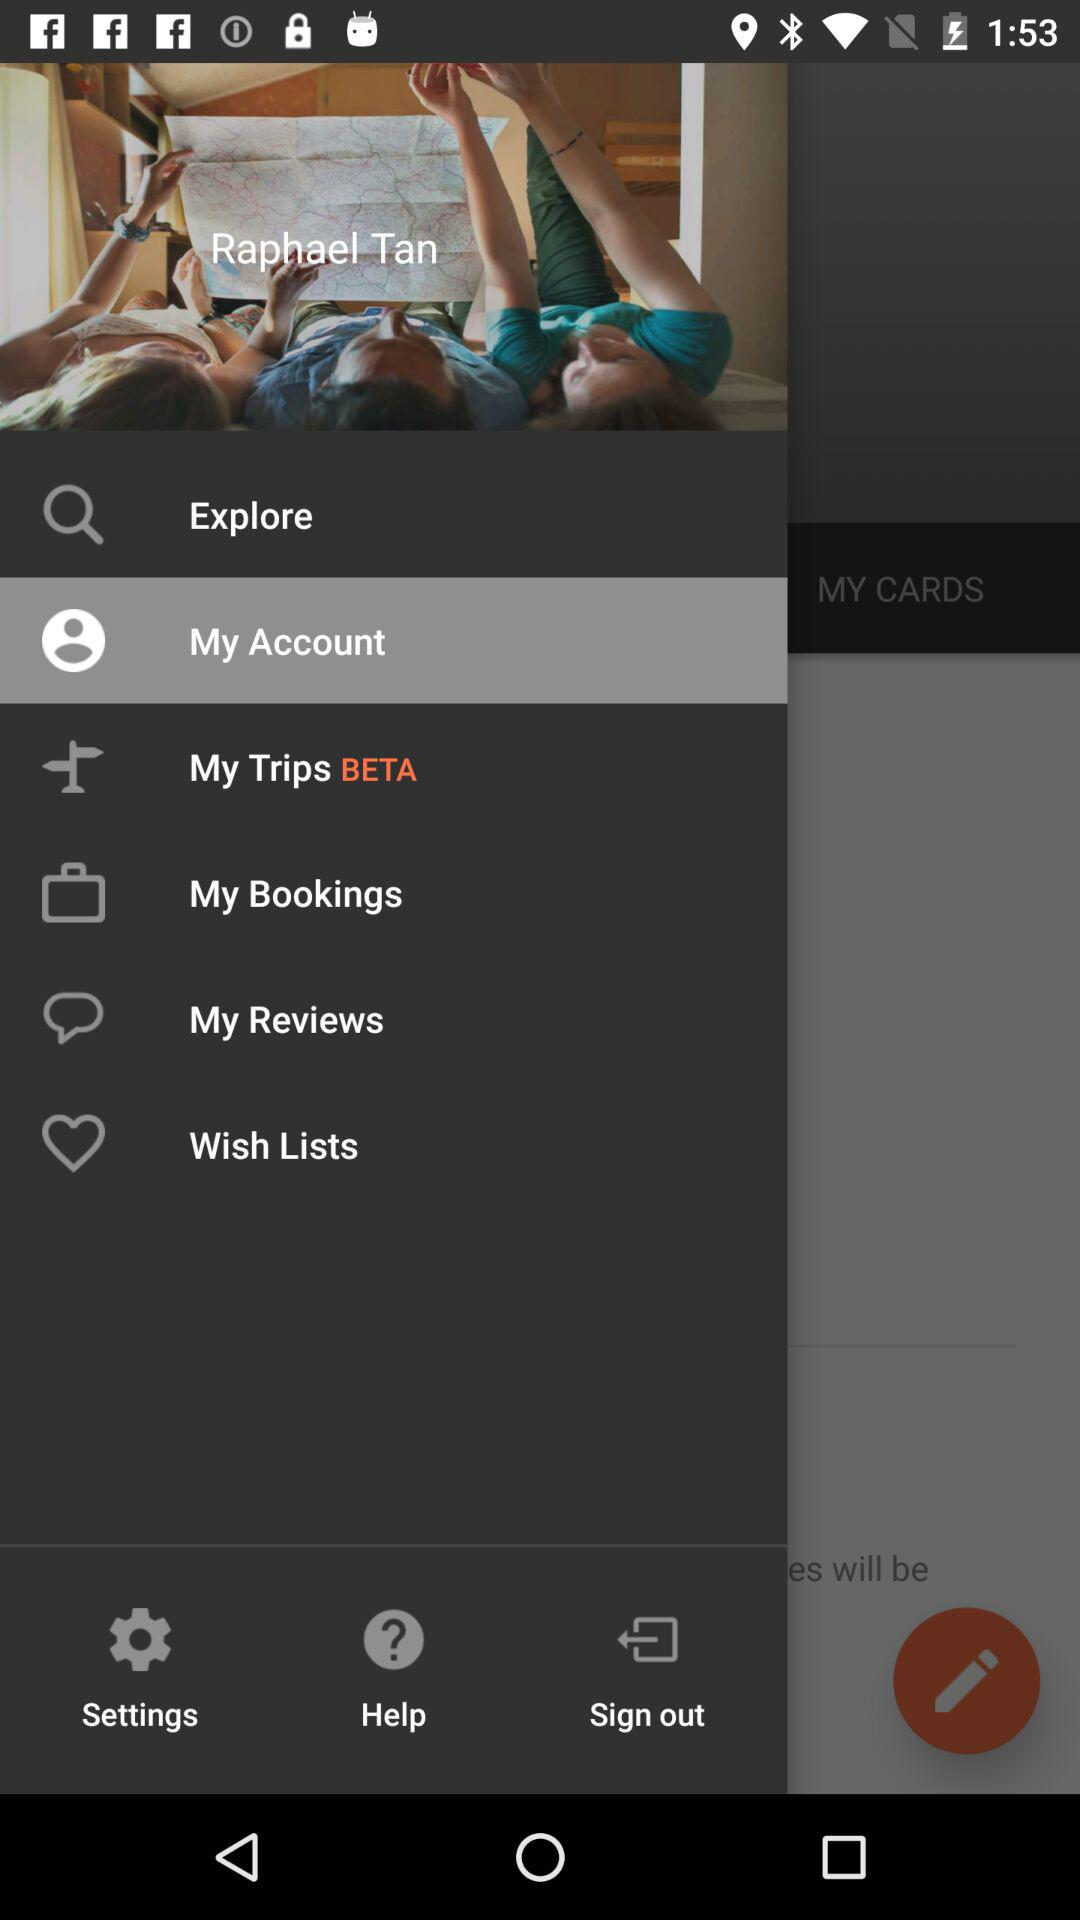What is the name of the user? The name of the user is Raphael Tan. 